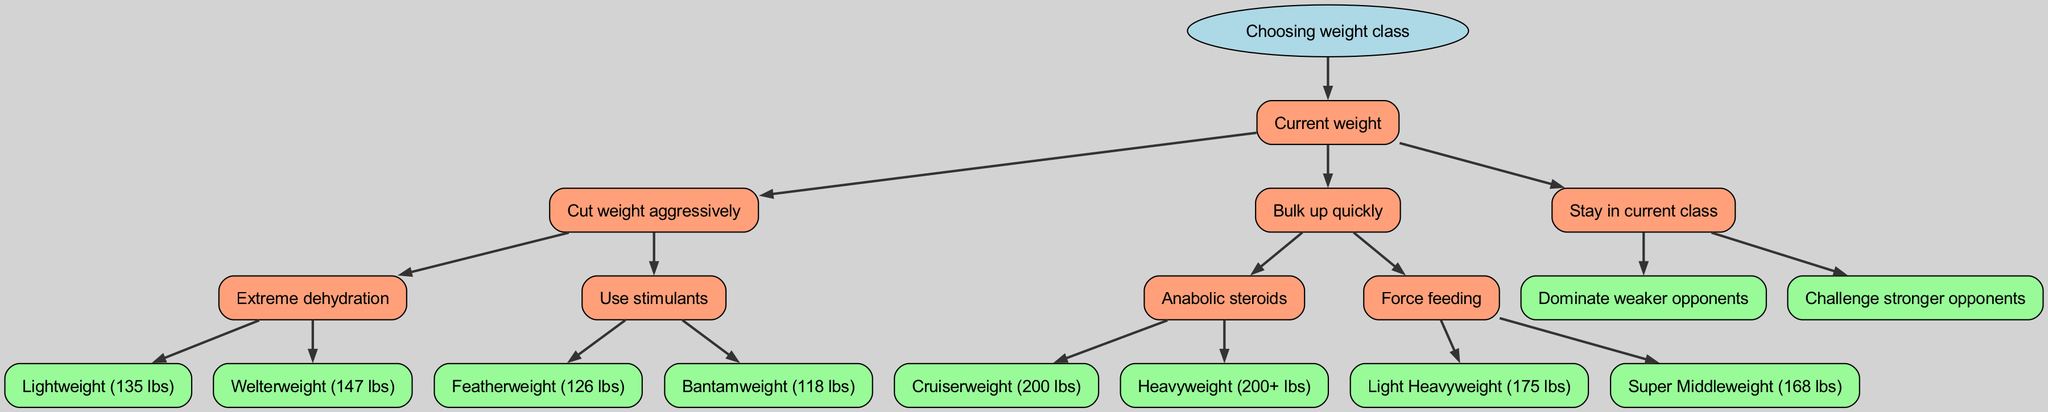What is the root node of the decision tree? The root node is labeled "Choosing weight class," and it is the starting point of the diagram that branches out into different weight-related decisions.
Answer: Choosing weight class How many child nodes does the "current weight" node have? The "current weight" node has three child nodes: "cut weight," "bulk up," and "stay." Counting these gives us a total of three child nodes.
Answer: 3 Which weight class can be achieved through "extreme dehydration"? The flow indicates that "extreme dehydration" leads to either "lightweight" or "welterweight," providing two possible classes stemming from that decision.
Answer: lightweight, welterweight What are the possible outcomes if a boxer decides to "bulk up quickly"? From "bulk up quickly," the options branch out to using "steroids" (leading to "cruiserweight" and "heavyweight") or "force feeding" (leading to "light heavyweight" and "super middleweight"). This decision leads to four potential weight classes overall.
Answer: cruiserweight, heavyweight, light heavyweight, super middleweight If a boxer chooses to "stay" in their current class, what are the two types of opponents they could face? The options from the "stay" node branch into facing "weaker opponents" or "stronger opponents," indicating the types of competitors in that weight class.
Answer: weaker opponents, stronger opponents Which node leads to the "featherweight" class? The "use stimulants" decision node from the "cut weight aggressively" node leads directly to the "featherweight" class, indicating a specific path through the decision tree.
Answer: featherweight If a boxer is at a point of "cutting weight aggressively," what are the two methods described next? The methods available after the "cut weight aggressively" decision are "dehydration" and "stimulants," showing two distinct approaches to achieving weight loss.
Answer: dehydration, stimulants What is the weight limit for the "light heavyweight" class? According to the diagram, the "light heavyweight" class is specified as being 175 lbs, giving clear information about the upper weight boundary for this classification.
Answer: 175 lbs 